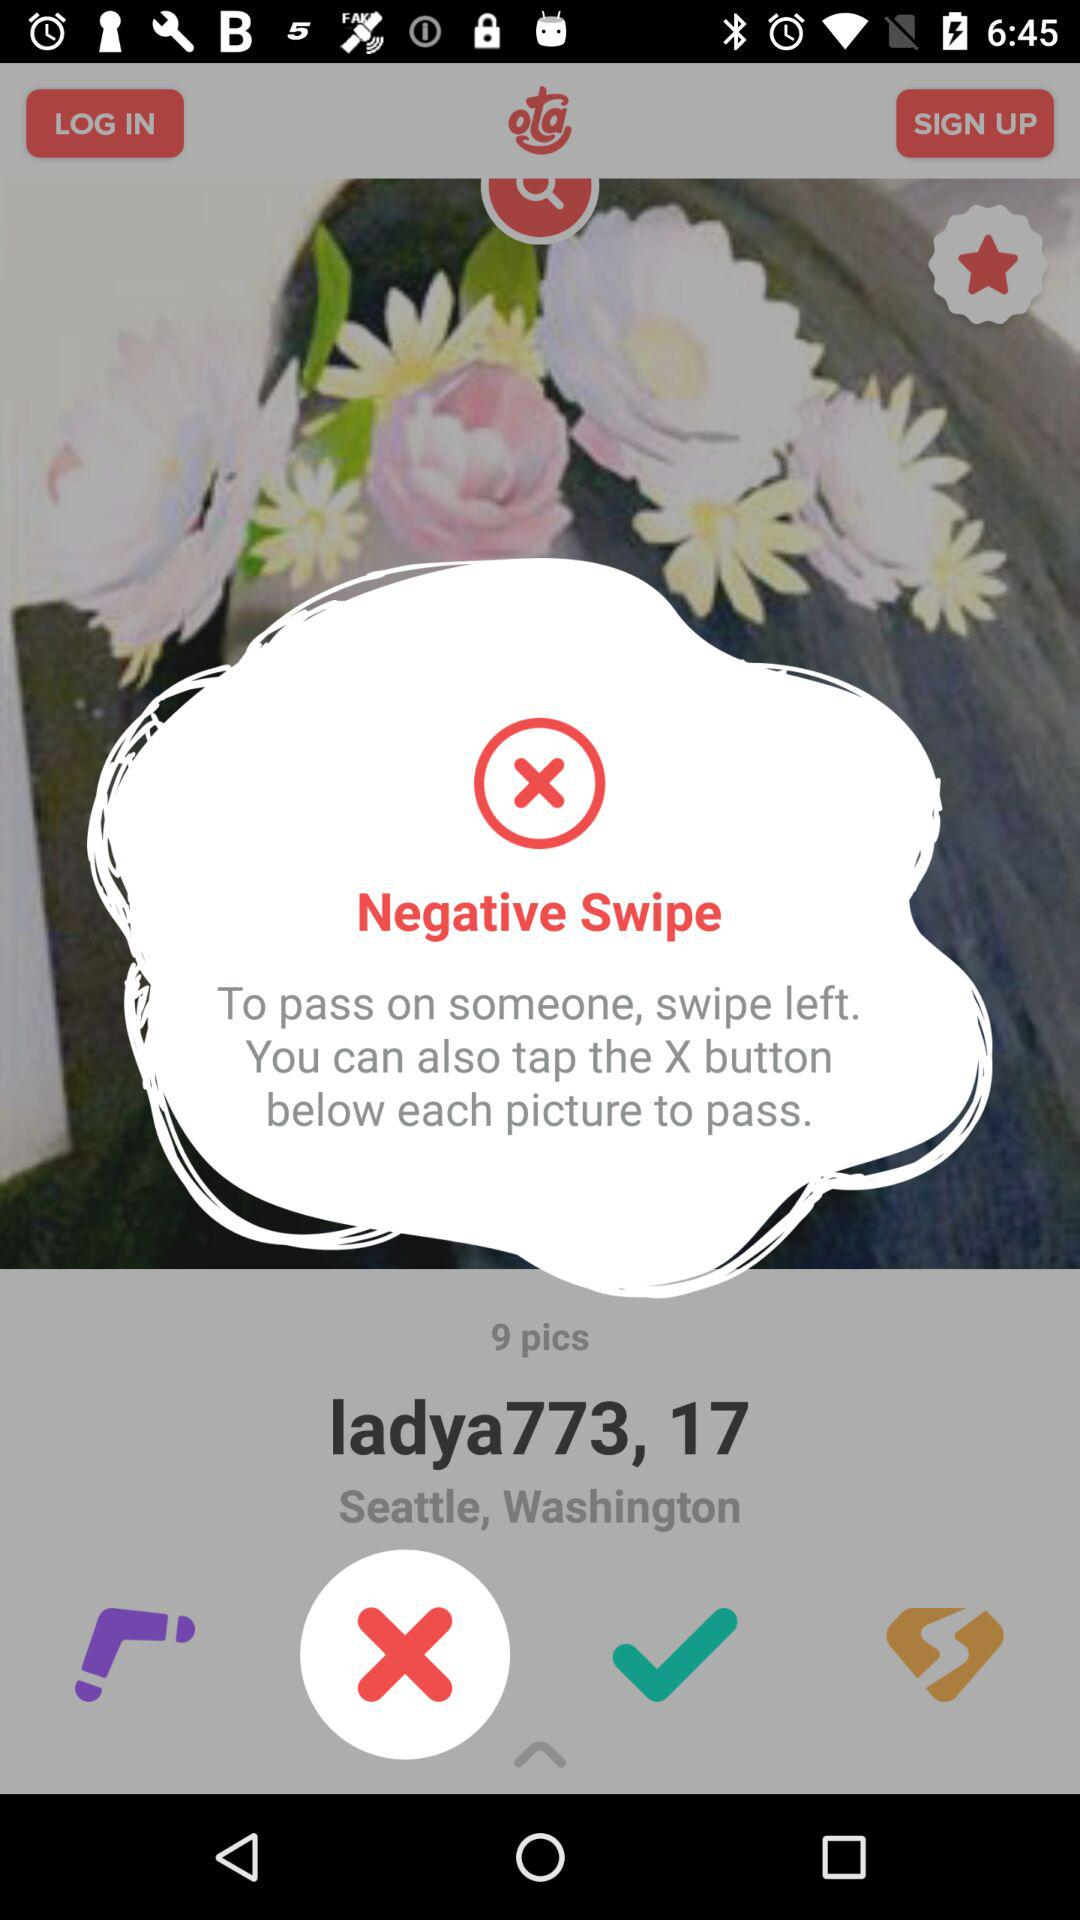How many total pics are there? There are total 9 pics. 